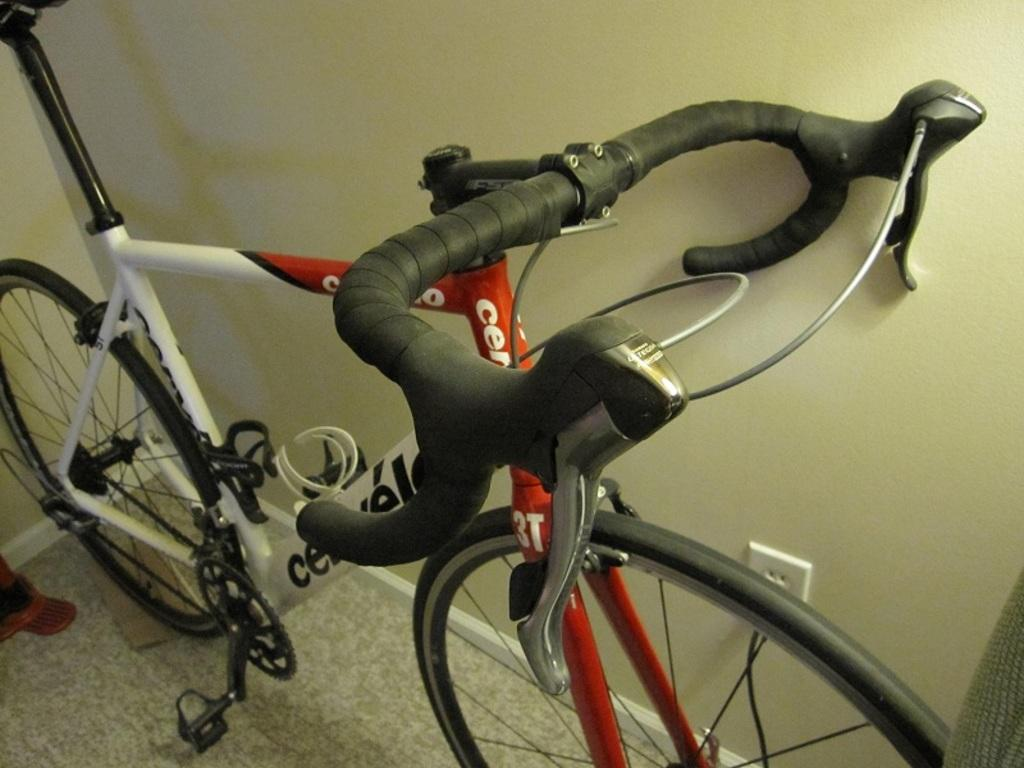What is the main object in the middle of the image? There is a bicycle in the middle of the image. What can be seen in the background of the image? There is a wall in the background of the image. What part of the image shows the surface on which the bicycle is placed? The floor is visible on the bottom left side of the image. What type of wrench is being used to fix the bicycle in the image? There is no wrench or bicycle repair in the image; it only shows a bicycle and a wall in the background. 